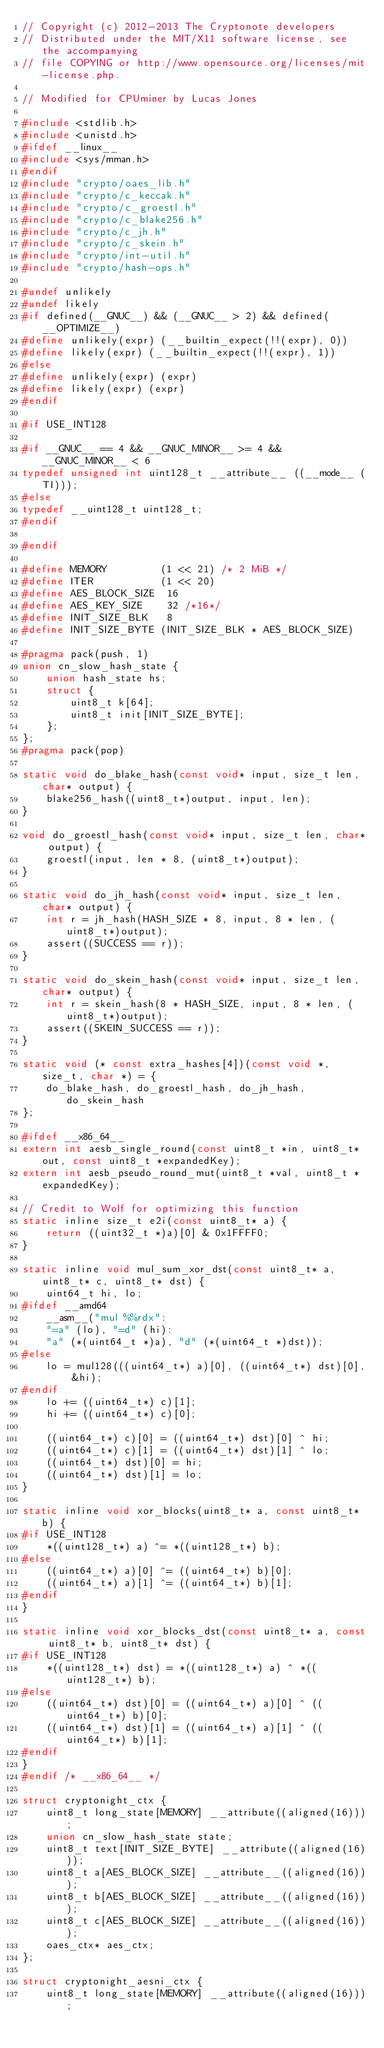Convert code to text. <code><loc_0><loc_0><loc_500><loc_500><_C_>// Copyright (c) 2012-2013 The Cryptonote developers
// Distributed under the MIT/X11 software license, see the accompanying
// file COPYING or http://www.opensource.org/licenses/mit-license.php.

// Modified for CPUminer by Lucas Jones

#include <stdlib.h>
#include <unistd.h>
#ifdef __linux__
#include <sys/mman.h>
#endif
#include "crypto/oaes_lib.h"
#include "crypto/c_keccak.h"
#include "crypto/c_groestl.h"
#include "crypto/c_blake256.h"
#include "crypto/c_jh.h"
#include "crypto/c_skein.h"
#include "crypto/int-util.h"
#include "crypto/hash-ops.h"

#undef unlikely
#undef likely
#if defined(__GNUC__) && (__GNUC__ > 2) && defined(__OPTIMIZE__)
#define unlikely(expr) (__builtin_expect(!!(expr), 0))
#define likely(expr) (__builtin_expect(!!(expr), 1))
#else
#define unlikely(expr) (expr)
#define likely(expr) (expr)
#endif

#if USE_INT128

#if __GNUC__ == 4 && __GNUC_MINOR__ >= 4 && __GNUC_MINOR__ < 6
typedef unsigned int uint128_t __attribute__ ((__mode__ (TI)));
#else
typedef __uint128_t uint128_t;
#endif

#endif

#define MEMORY         (1 << 21) /* 2 MiB */
#define ITER           (1 << 20)
#define AES_BLOCK_SIZE  16
#define AES_KEY_SIZE    32 /*16*/
#define INIT_SIZE_BLK   8
#define INIT_SIZE_BYTE (INIT_SIZE_BLK * AES_BLOCK_SIZE)

#pragma pack(push, 1)
union cn_slow_hash_state {
	union hash_state hs;
	struct {
		uint8_t k[64];
		uint8_t init[INIT_SIZE_BYTE];
	};
};
#pragma pack(pop)

static void do_blake_hash(const void* input, size_t len, char* output) {
	blake256_hash((uint8_t*)output, input, len);
}

void do_groestl_hash(const void* input, size_t len, char* output) {
	groestl(input, len * 8, (uint8_t*)output);
}

static void do_jh_hash(const void* input, size_t len, char* output) {
	int r = jh_hash(HASH_SIZE * 8, input, 8 * len, (uint8_t*)output);
	assert((SUCCESS == r));
}

static void do_skein_hash(const void* input, size_t len, char* output) {
	int r = skein_hash(8 * HASH_SIZE, input, 8 * len, (uint8_t*)output);
	assert((SKEIN_SUCCESS == r));
}

static void (* const extra_hashes[4])(const void *, size_t, char *) = {
	do_blake_hash, do_groestl_hash, do_jh_hash, do_skein_hash
};

#ifdef __x86_64__
extern int aesb_single_round(const uint8_t *in, uint8_t*out, const uint8_t *expandedKey);
extern int aesb_pseudo_round_mut(uint8_t *val, uint8_t *expandedKey);

// Credit to Wolf for optimizing this function
static inline size_t e2i(const uint8_t* a) {
	return ((uint32_t *)a)[0] & 0x1FFFF0;
}

static inline void mul_sum_xor_dst(const uint8_t* a, uint8_t* c, uint8_t* dst) {
	uint64_t hi, lo;
#ifdef __amd64
	__asm__("mul %%rdx":
	"=a" (lo), "=d" (hi):
	"a" (*(uint64_t *)a), "d" (*(uint64_t *)dst));
#else
	lo = mul128(((uint64_t*) a)[0], ((uint64_t*) dst)[0], &hi);
#endif
	lo += ((uint64_t*) c)[1];
	hi += ((uint64_t*) c)[0];

	((uint64_t*) c)[0] = ((uint64_t*) dst)[0] ^ hi;
	((uint64_t*) c)[1] = ((uint64_t*) dst)[1] ^ lo;
	((uint64_t*) dst)[0] = hi;
	((uint64_t*) dst)[1] = lo;
}

static inline void xor_blocks(uint8_t* a, const uint8_t* b) {
#if USE_INT128
	*((uint128_t*) a) ^= *((uint128_t*) b);
#else
	((uint64_t*) a)[0] ^= ((uint64_t*) b)[0];
	((uint64_t*) a)[1] ^= ((uint64_t*) b)[1];
#endif
}

static inline void xor_blocks_dst(const uint8_t* a, const uint8_t* b, uint8_t* dst) {
#if USE_INT128
	*((uint128_t*) dst) = *((uint128_t*) a) ^ *((uint128_t*) b);
#else
	((uint64_t*) dst)[0] = ((uint64_t*) a)[0] ^ ((uint64_t*) b)[0];
	((uint64_t*) dst)[1] = ((uint64_t*) a)[1] ^ ((uint64_t*) b)[1];
#endif
}
#endif /* __x86_64__ */

struct cryptonight_ctx {
	uint8_t long_state[MEMORY] __attribute((aligned(16)));
	union cn_slow_hash_state state;
	uint8_t text[INIT_SIZE_BYTE] __attribute((aligned(16)));
	uint8_t a[AES_BLOCK_SIZE] __attribute__((aligned(16)));
	uint8_t b[AES_BLOCK_SIZE] __attribute__((aligned(16)));
	uint8_t c[AES_BLOCK_SIZE] __attribute__((aligned(16)));
	oaes_ctx* aes_ctx;
};

struct cryptonight_aesni_ctx {
    uint8_t long_state[MEMORY] __attribute((aligned(16)));</code> 